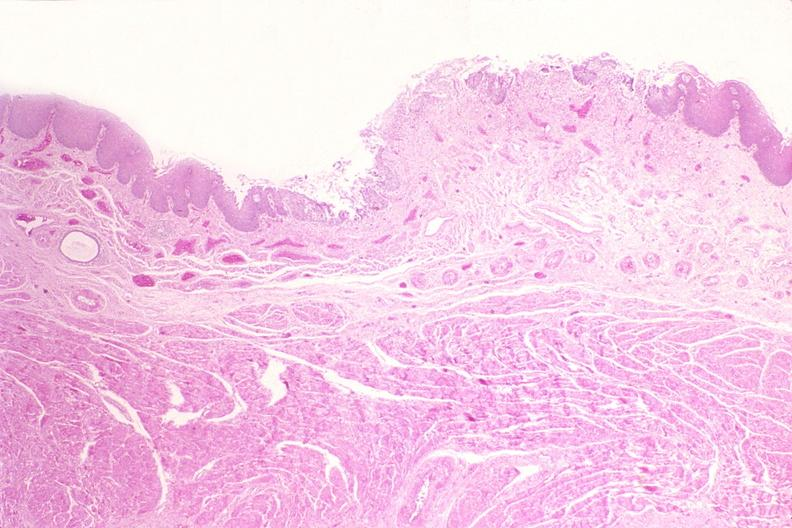what is present?
Answer the question using a single word or phrase. Gastrointestinal 